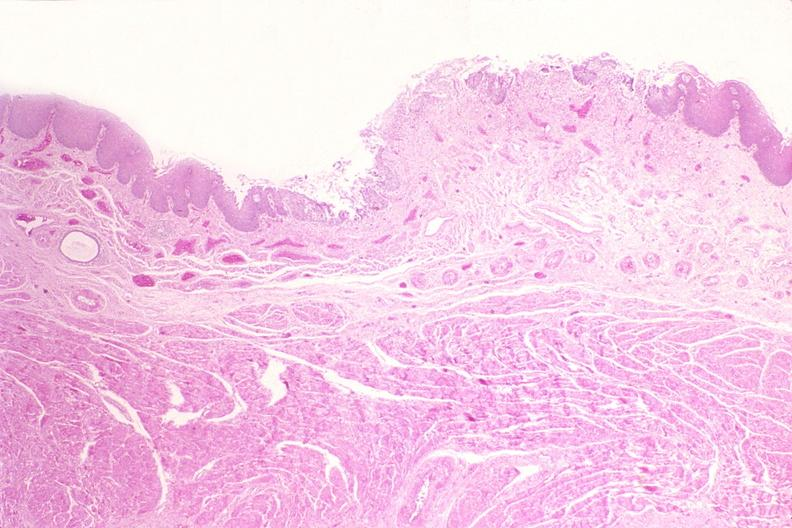what is present?
Answer the question using a single word or phrase. Gastrointestinal 